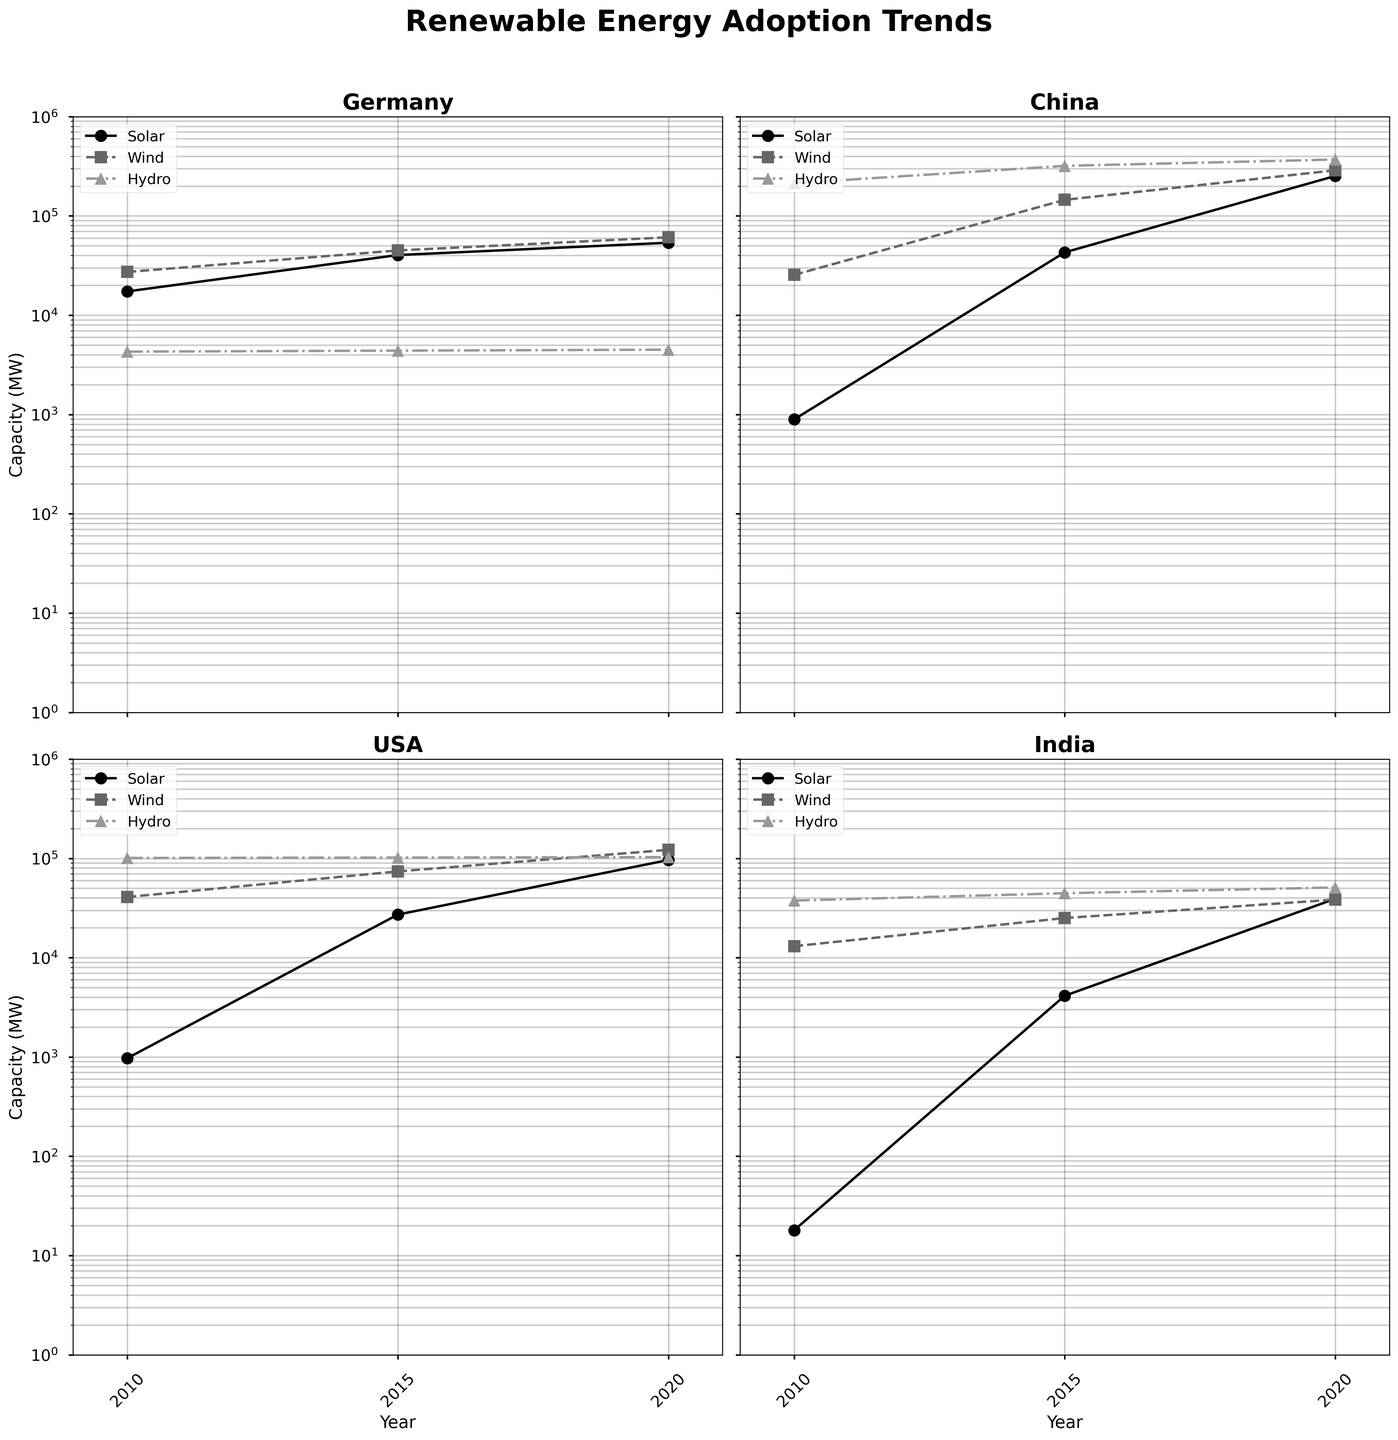What country has the highest increase in solar power capacity from 2010 to 2020? To find the country with the highest increase, observe the data points for solar power for each country in 2010 and 2020. Calculate the difference for each country and identify the country with the largest increase. China shows an increase from 893 MW in 2010 to 253,000 MW in 2020.
Answer: China What is the capacity of wind power in Germany in 2015? Locate Germany's subplot and observe the data points for wind power in 2015. The wind power capacity is around 44,947 MW.
Answer: 44,947 MW Which country shows the least growth in hydro power capacity from 2010 to 2020? Examine the figures for hydro power in 2010 and 2020 for all countries. Calculate the growth for each. Germany's hydro growth is from 4,300 MW to 4,500 MW, which is the smallest increase of 200 MW.
Answer: Germany How does the growth rate of solar power in the USA from 2010 to 2015 compare to the growth rate from 2015 to 2020? Observe the USA's solar power capacity for the years 2010, 2015, and 2020 on its subplot. Calculate the growth rate for both time periods. 2010 to 2015 shows an increase from 972 MW to 27,176 MW (approximately 27.95x), while 2015 to 2020 shows an increase from 27,176 MW to 96,439 MW (approximately 3.55x).
Answer: Faster growth from 2010 to 2015 Which renewable energy type has the consistently highest capacity in China from 2010 to 2020? Observe China's subplot and compare the heights of the data points for solar, wind, and hydro power across all years. Hydro power has the consistently highest capacity.
Answer: Hydro power What is the combined capacity of wind power in China and the USA in 2020? Locate the data points for wind power in China and the USA in the year 2020. Add the capacities: China (288,320 MW) and USA (122,000 MW) result in a combined capacity of 410,320 MW.
Answer: 410,320 MW Which country shows the steepest increase in renewable energy capacity in solar power around 2015? Compare the slopes of the lines for solar power around 2015 in all countries' subplots. China demonstrates the steepest increase from around 893 MW in 2010 to 43,000 MW in 2015.
Answer: China What is the approximate total renewable energy capacity (solar, wind, hydro) for India in 2020? Sum the capacities of India for solar, wind, and hydro power in 2020: Solar (39,240 MW), Wind (38,454 MW), and Hydro (50,996 MW). The total is approximately 128,690 MW.
Answer: 128,690 MW 